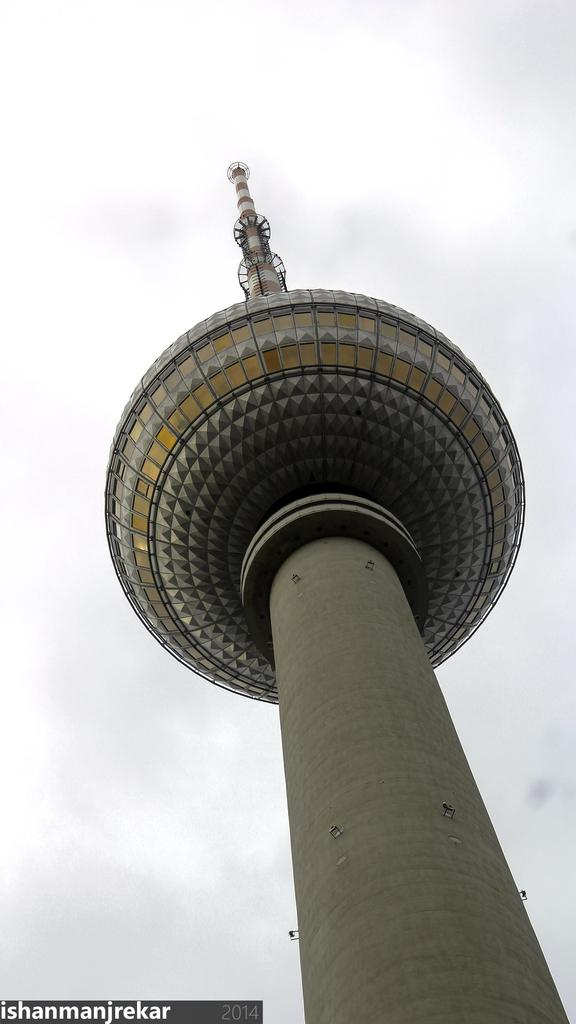What is the main structure in the image? There is a tower in the image. How would you describe the sky in the image? The sky is cloudy in the image. Can you find any text in the image? Yes, there are texts at the bottom of the image. How does the light from the sun affect the tower in the image? The image does not show the sun, so we cannot determine how the light from the sun affects the tower. 